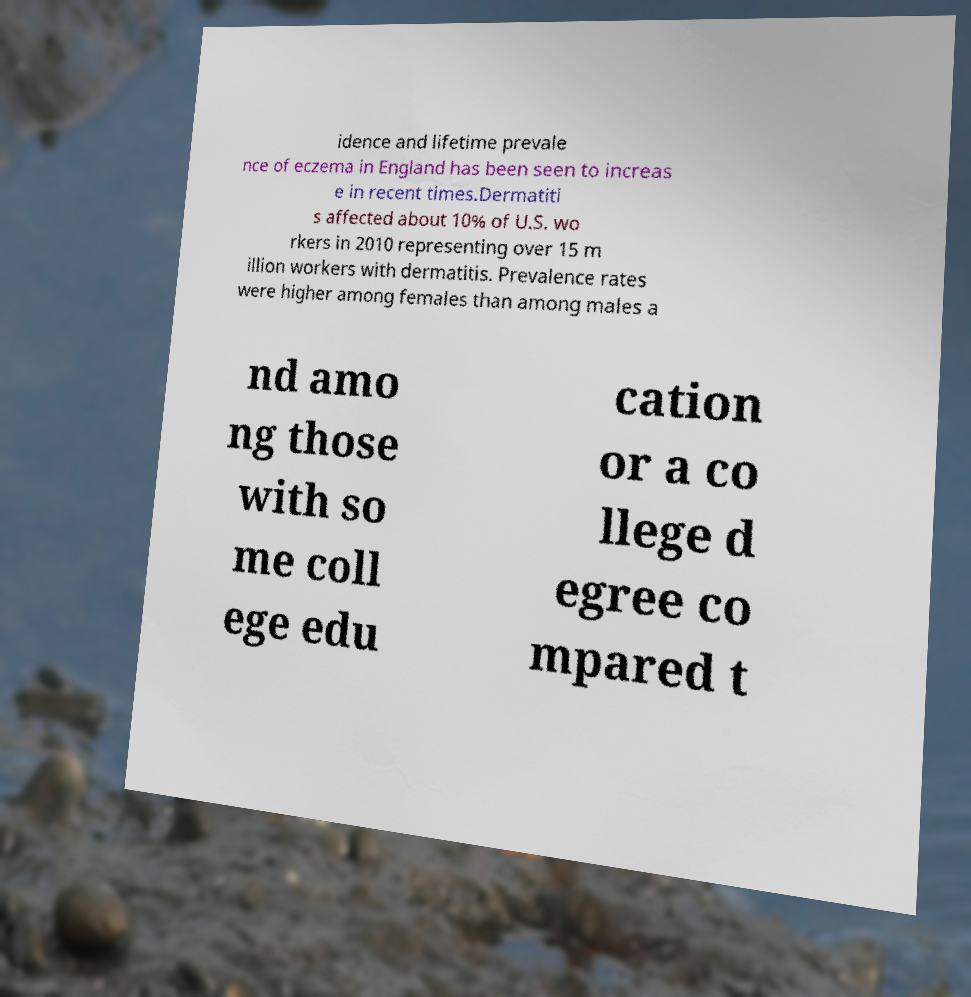Could you assist in decoding the text presented in this image and type it out clearly? idence and lifetime prevale nce of eczema in England has been seen to increas e in recent times.Dermatiti s affected about 10% of U.S. wo rkers in 2010 representing over 15 m illion workers with dermatitis. Prevalence rates were higher among females than among males a nd amo ng those with so me coll ege edu cation or a co llege d egree co mpared t 